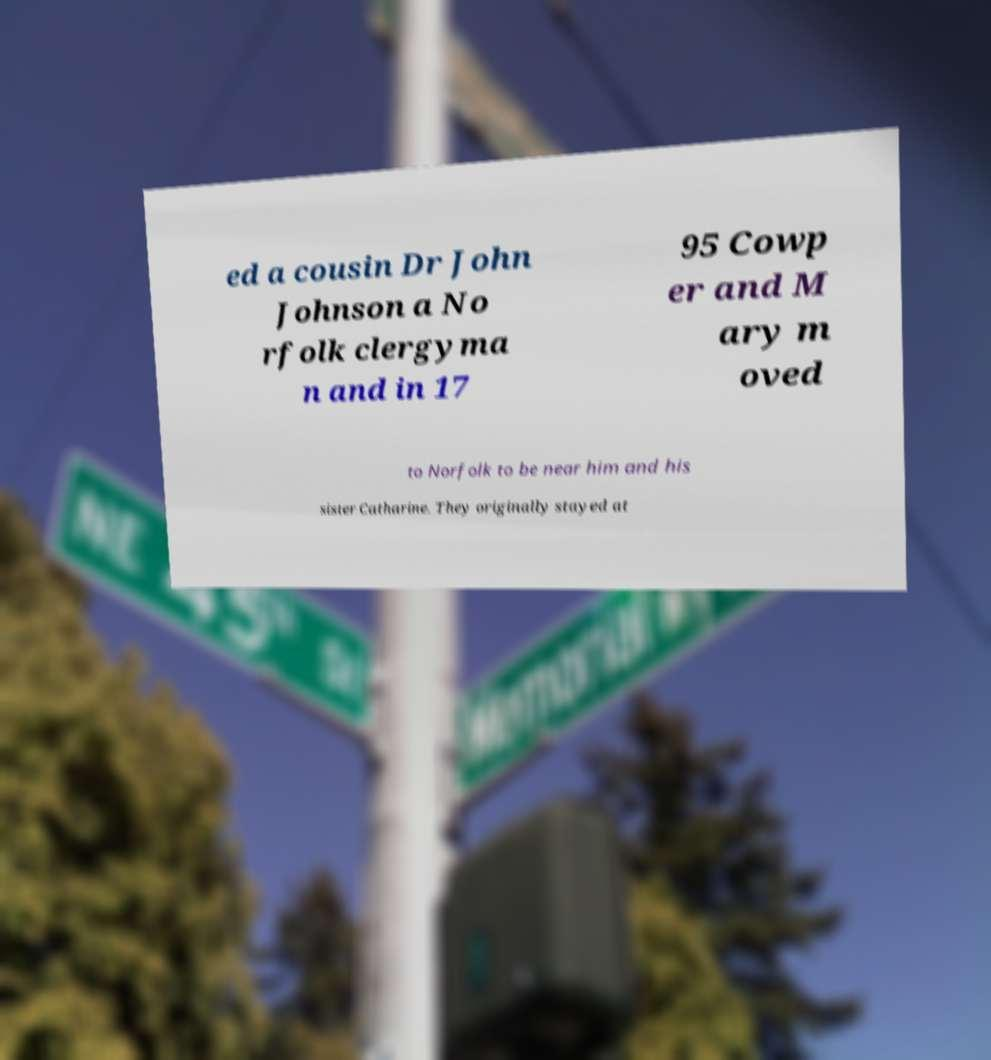Can you read and provide the text displayed in the image?This photo seems to have some interesting text. Can you extract and type it out for me? ed a cousin Dr John Johnson a No rfolk clergyma n and in 17 95 Cowp er and M ary m oved to Norfolk to be near him and his sister Catharine. They originally stayed at 